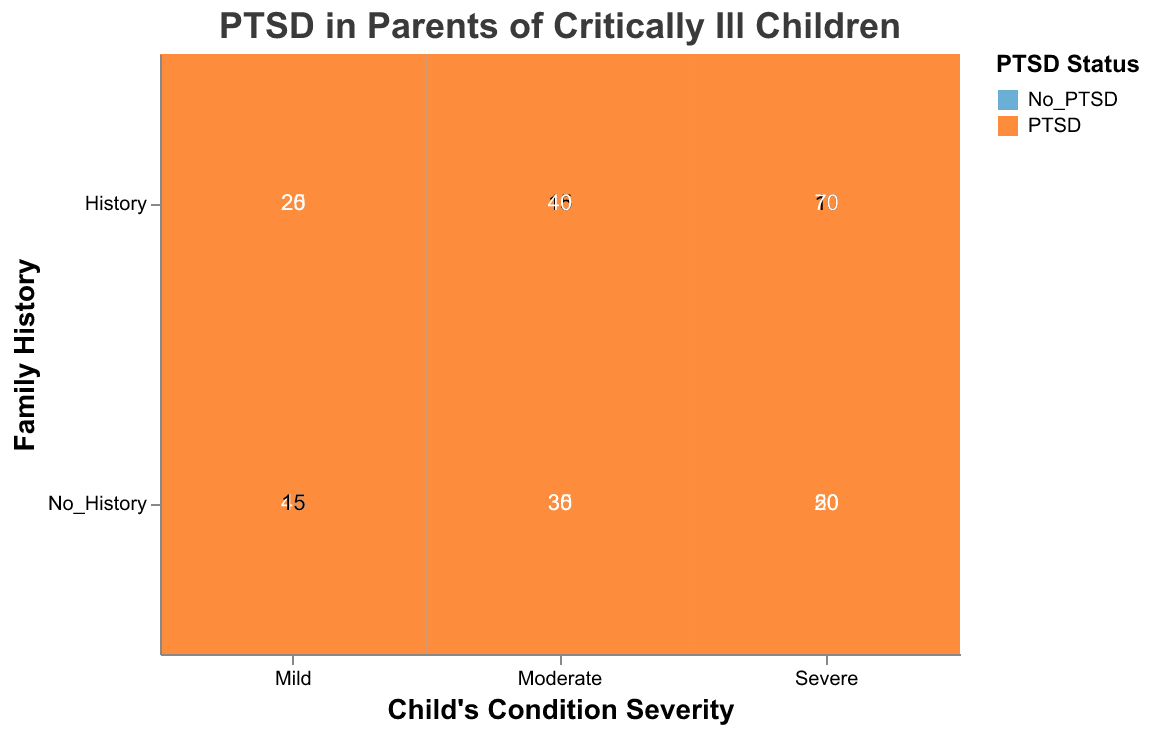What is the title of the plot? The title is found at the top of the plot and indicates the main subject. It reads "PTSD in Parents of Critically Ill Children."
Answer: PTSD in Parents of Critically Ill Children Which axis represents the child's condition severity? Looking at the labels, the horizontal (x) axis represents different levels of the child's condition severity, labeled as "Mild," "Moderate," and "Severe."
Answer: The horizontal axis What color represents parents with PTSD? The color legend shows two colors: one for "No_PTSD" in light blue and one for "PTSD" in orange.
Answer: Orange How many parents had PTSD with a family history among children with severe conditions? In the intersection of "Severe" and "History" under PTSD, the count displayed is 70.
Answer: 70 Which group has more cases of PTSD: parents with a family history of PTSD or those without, in moderate severity cases? We compare the "History" and "No_History" sections under "Moderate." The counts are 40 for "History" and 30 for "No_History," showing more cases in parents with a family history.
Answer: Parents with a family history What is the total count of parents without PTSD in all categories of child's condition severity? Sum the counts for "No_PTSD" across all severities: 45 (Mild, No_History), 20 (Mild, History), 35 (Moderate, No_History), 15 (Moderate, History), 20 (Severe, No_History), 10 (Severe, History). So, 45+20+35+15+20+10 = 145.
Answer: 145 Among parents of children with mild conditions, is PTSD more prevalent in those with or without a family history? Comparing "History" (25) and "No_History" (15) counts among the "Mild" section shows higher prevalence in those with a family history.
Answer: Parents with a family history What is the ratio of PTSD to No PTSD among parents of children with moderate conditions and no family history? For "Moderate" and "No_History," the counts are 30 for PTSD and 35 for No PTSD. The ratio is calculated as 30/35, which simplifies to approximately 0.86.
Answer: Approximately 0.86 Which combination of severity and family history has the least number of parents with PTSD? Comparing all counts under PTSD across the categories, the smallest number is 15 in "Mild" and "No_History."
Answer: Mild and No_History How many more parents have PTSD than No PTSD in severe conditions with family history? For "Severe" and "History," PTSD count is 70 and No PTSD count is 10. The difference is 70 - 10 = 60.
Answer: 60 